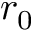<formula> <loc_0><loc_0><loc_500><loc_500>r _ { 0 }</formula> 